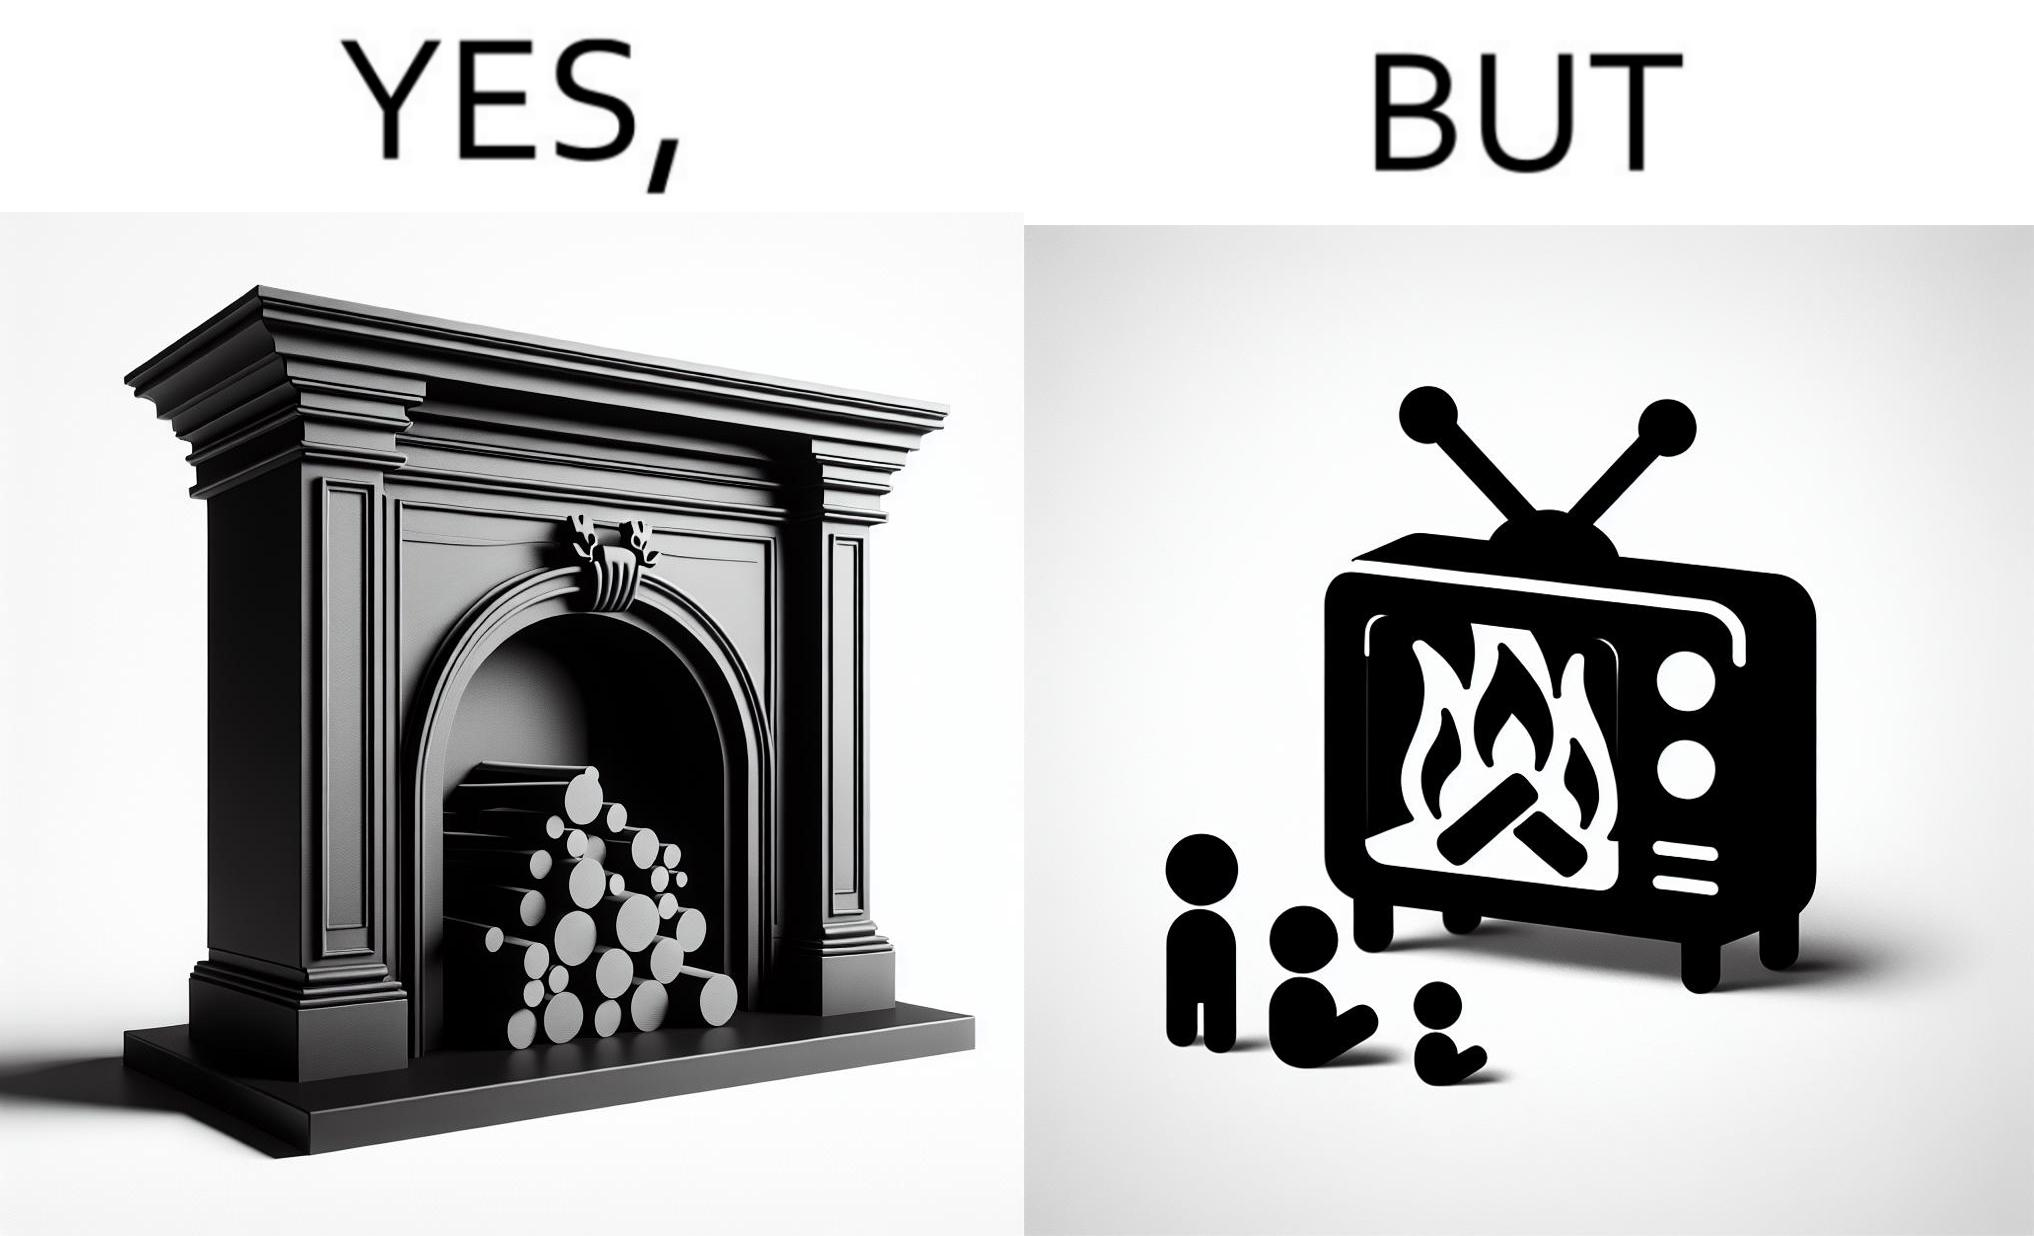Describe the contrast between the left and right parts of this image. In the left part of the image: It is a fireplace In the right part of the image: It a fireplace being displayed on a television screen 